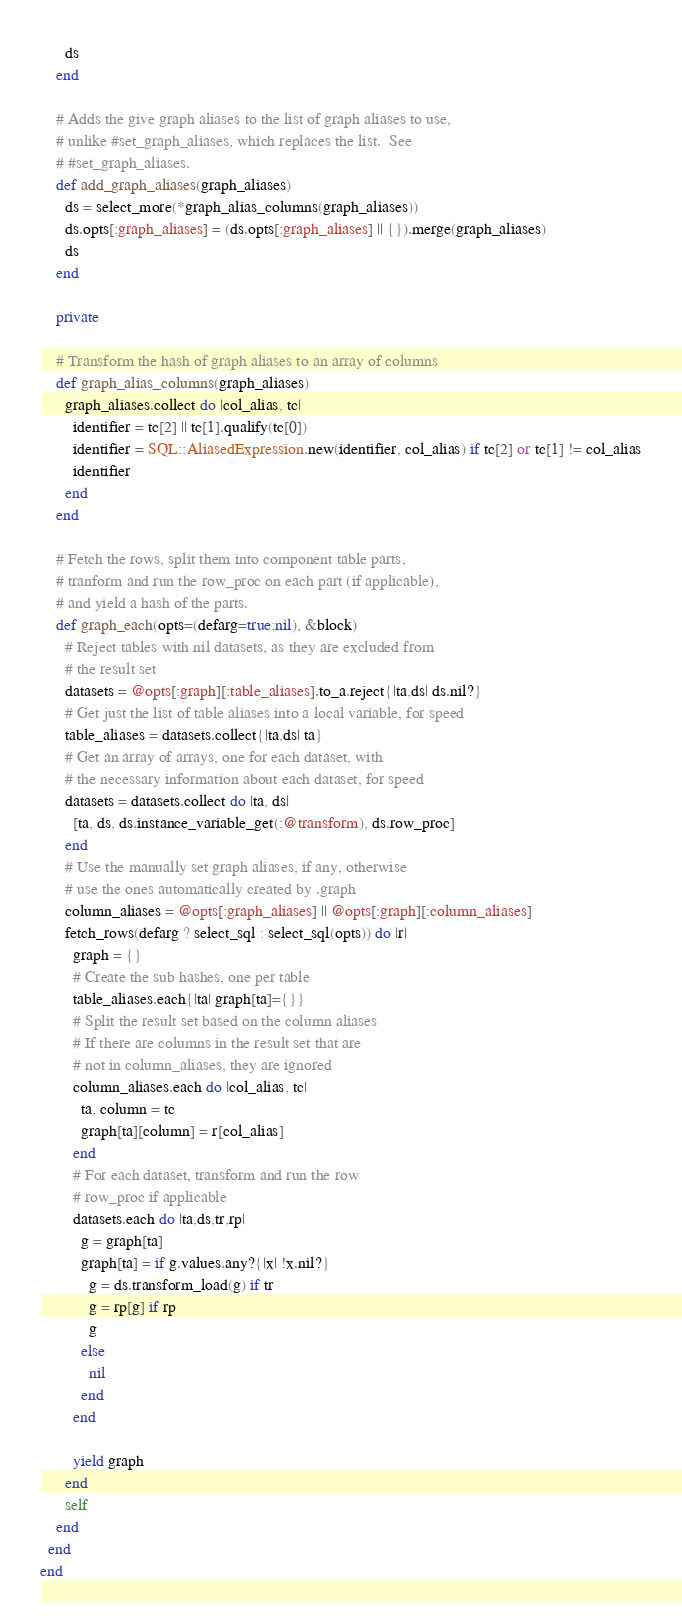Convert code to text. <code><loc_0><loc_0><loc_500><loc_500><_Ruby_>      ds
    end

    # Adds the give graph aliases to the list of graph aliases to use,
    # unlike #set_graph_aliases, which replaces the list.  See
    # #set_graph_aliases.
    def add_graph_aliases(graph_aliases)
      ds = select_more(*graph_alias_columns(graph_aliases))
      ds.opts[:graph_aliases] = (ds.opts[:graph_aliases] || {}).merge(graph_aliases)
      ds
    end

    private

    # Transform the hash of graph aliases to an array of columns
    def graph_alias_columns(graph_aliases)
      graph_aliases.collect do |col_alias, tc| 
        identifier = tc[2] || tc[1].qualify(tc[0])
        identifier = SQL::AliasedExpression.new(identifier, col_alias) if tc[2] or tc[1] != col_alias
        identifier
      end
    end

    # Fetch the rows, split them into component table parts,
    # tranform and run the row_proc on each part (if applicable),
    # and yield a hash of the parts.
    def graph_each(opts=(defarg=true;nil), &block)
      # Reject tables with nil datasets, as they are excluded from
      # the result set
      datasets = @opts[:graph][:table_aliases].to_a.reject{|ta,ds| ds.nil?}
      # Get just the list of table aliases into a local variable, for speed
      table_aliases = datasets.collect{|ta,ds| ta}
      # Get an array of arrays, one for each dataset, with
      # the necessary information about each dataset, for speed
      datasets = datasets.collect do |ta, ds|
        [ta, ds, ds.instance_variable_get(:@transform), ds.row_proc]
      end
      # Use the manually set graph aliases, if any, otherwise
      # use the ones automatically created by .graph
      column_aliases = @opts[:graph_aliases] || @opts[:graph][:column_aliases]
      fetch_rows(defarg ? select_sql : select_sql(opts)) do |r|
        graph = {}
        # Create the sub hashes, one per table
        table_aliases.each{|ta| graph[ta]={}}
        # Split the result set based on the column aliases
        # If there are columns in the result set that are
        # not in column_aliases, they are ignored
        column_aliases.each do |col_alias, tc|
          ta, column = tc
          graph[ta][column] = r[col_alias]
        end
        # For each dataset, transform and run the row
        # row_proc if applicable
        datasets.each do |ta,ds,tr,rp|
          g = graph[ta]
          graph[ta] = if g.values.any?{|x| !x.nil?}
            g = ds.transform_load(g) if tr
            g = rp[g] if rp
            g
          else
            nil
          end
        end

        yield graph
      end
      self
    end
  end
end
</code> 